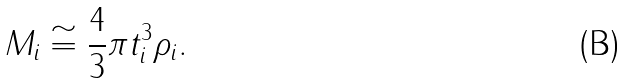Convert formula to latex. <formula><loc_0><loc_0><loc_500><loc_500>M _ { i } \cong \frac { 4 } { 3 } \pi t _ { i } ^ { 3 } \rho _ { i } .</formula> 